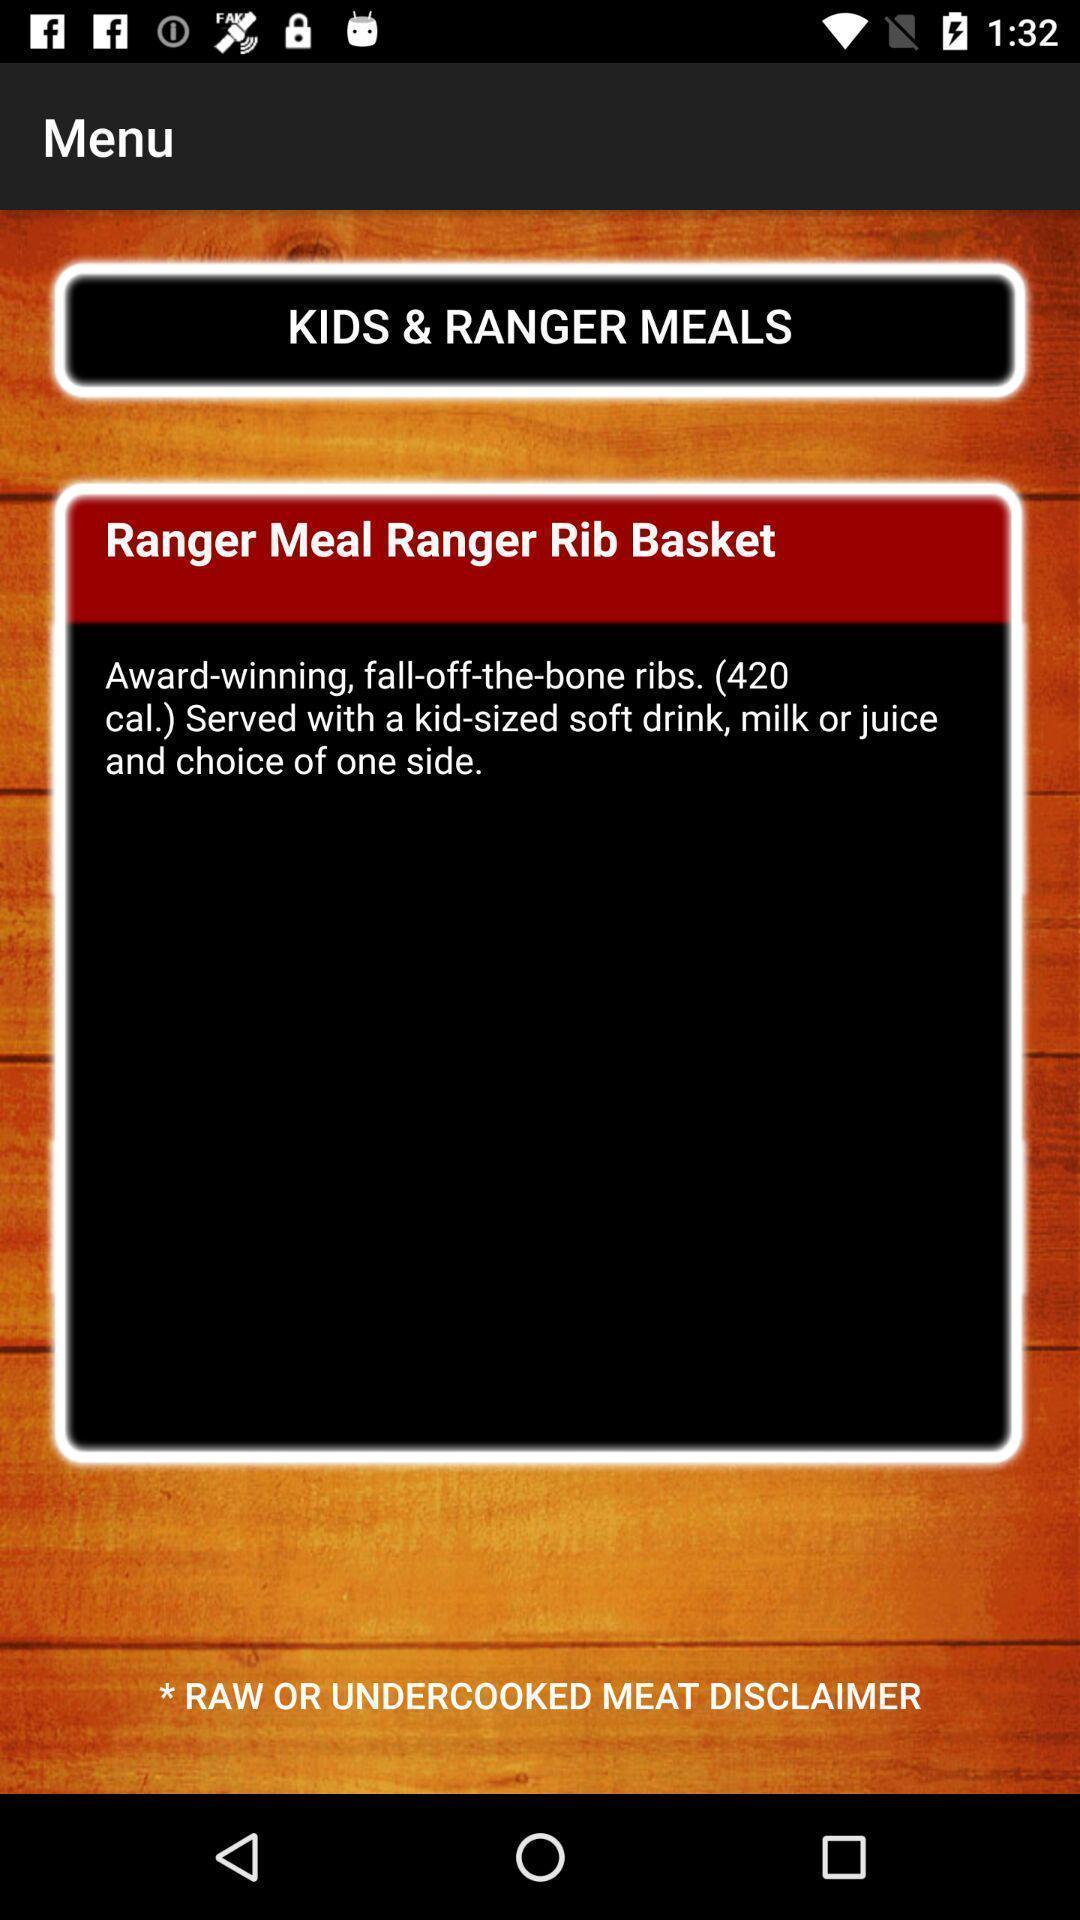Explain the elements present in this screenshot. Page displaying menu options. 